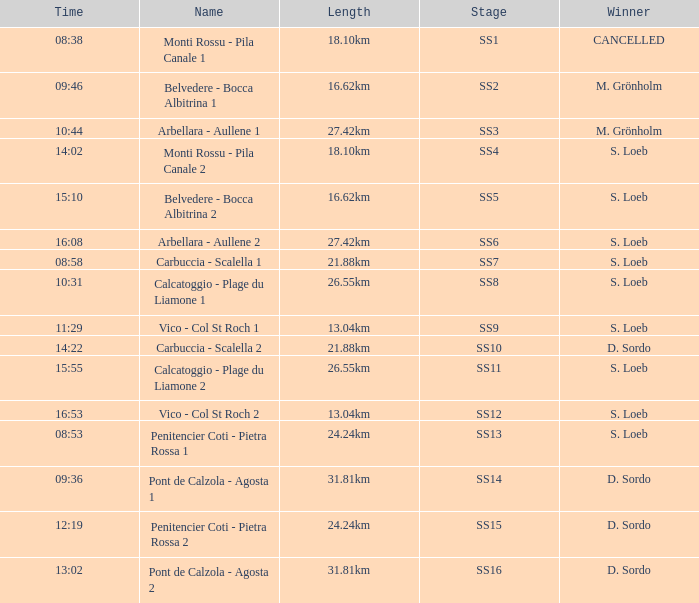What is the Name of the SS11 Stage? Calcatoggio - Plage du Liamone 2. 